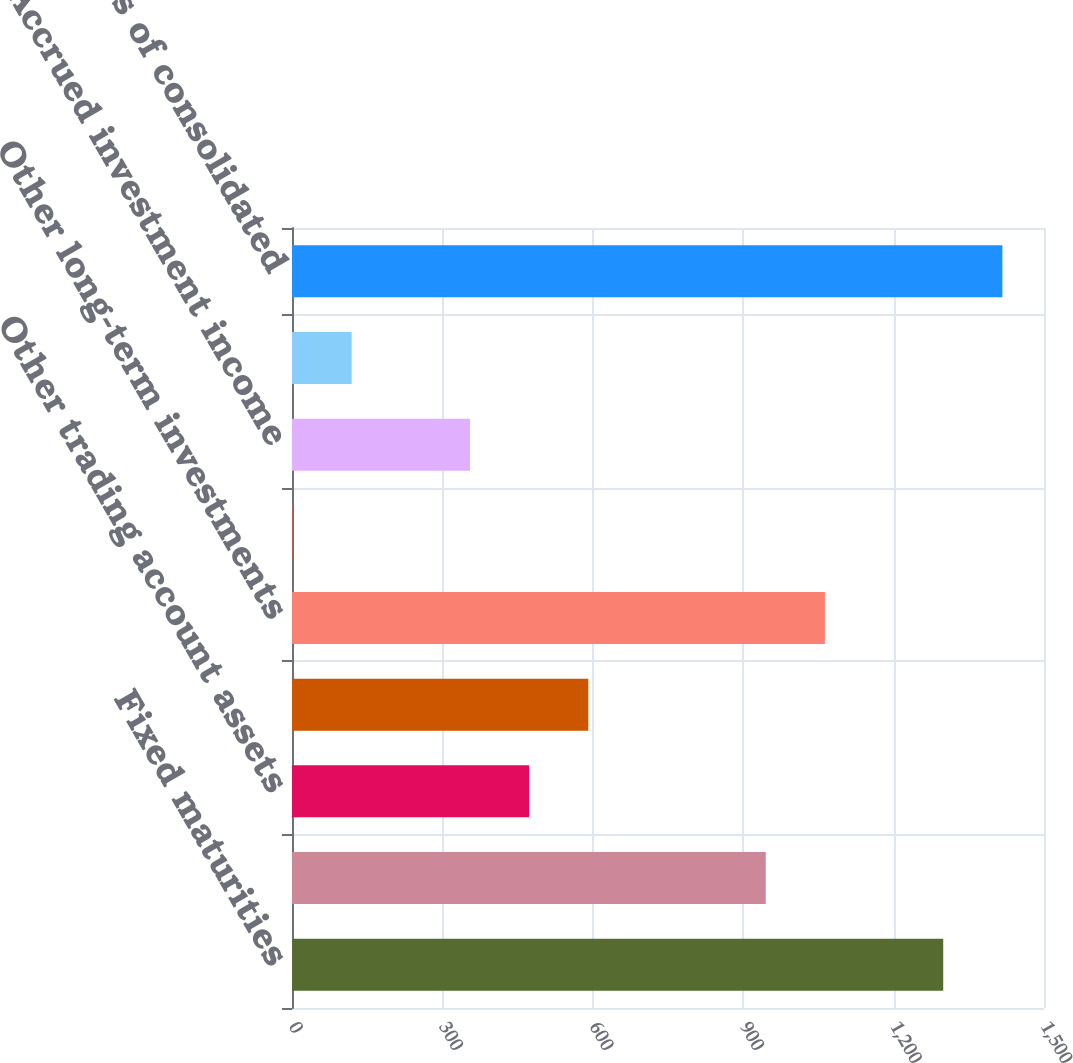Convert chart to OTSL. <chart><loc_0><loc_0><loc_500><loc_500><bar_chart><fcel>Fixed maturities<fcel>Trading account assets<fcel>Other trading account assets<fcel>Commercial mortgage and other<fcel>Other long-term investments<fcel>Cash and cash equivalents<fcel>Accrued investment income<fcel>Other assets<fcel>Total assets of consolidated<nl><fcel>1299<fcel>945<fcel>473<fcel>591<fcel>1063<fcel>1<fcel>355<fcel>119<fcel>1417<nl></chart> 